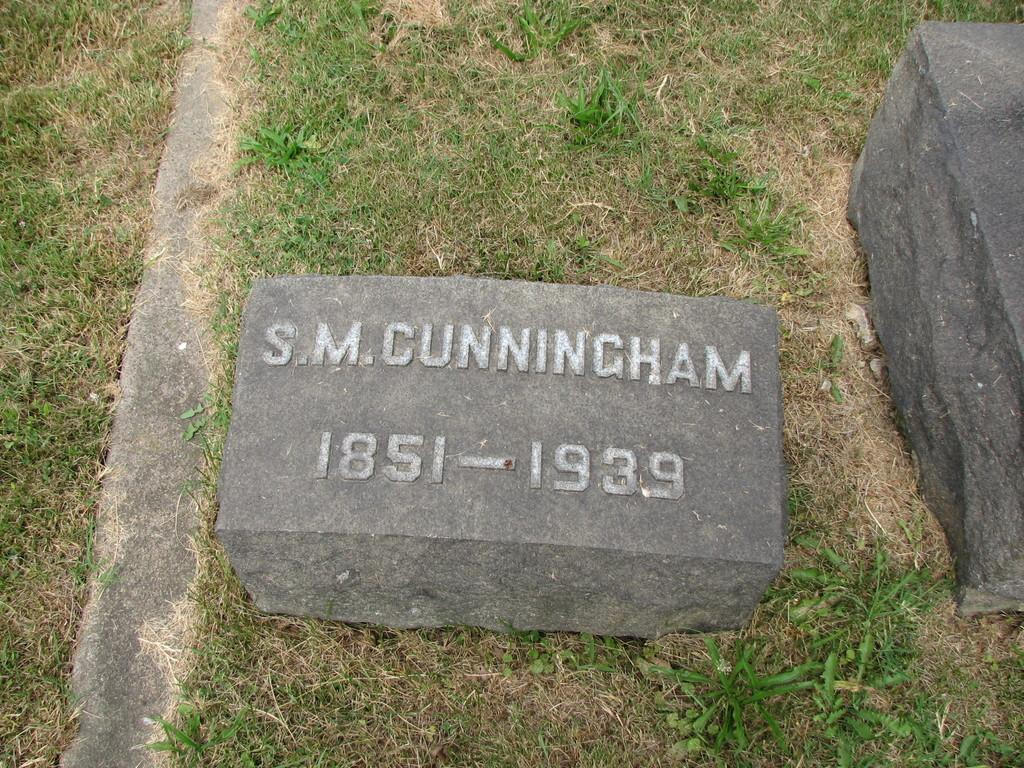What is the main subject in the foreground of the image? There is a headstone in the foreground of the image. What type of terrain is the headstone located on? The headstone is on a grassland. What information can be found on the headstone? There is text on the headstone. Are there any other stones visible in the image? Yes, there is another stone on the right side of the image. How many pizzas are being served at the event depicted in the image? There is no event or pizzas present in the image; it features a headstone on a grassland. What type of experience can be gained from observing the spiders in the image? There are no spiders present in the image, so no such experience can be gained. 